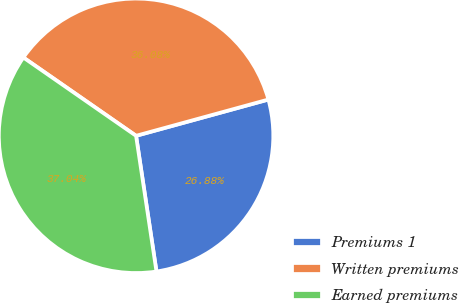<chart> <loc_0><loc_0><loc_500><loc_500><pie_chart><fcel>Premiums 1<fcel>Written premiums<fcel>Earned premiums<nl><fcel>26.88%<fcel>36.08%<fcel>37.04%<nl></chart> 